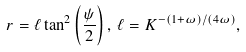<formula> <loc_0><loc_0><loc_500><loc_500>r = { \ell } \tan ^ { 2 } \left ( \frac { \psi } { 2 } \right ) , \, { \ell } = K ^ { - ( 1 + \omega ) / ( 4 \omega ) } ,</formula> 